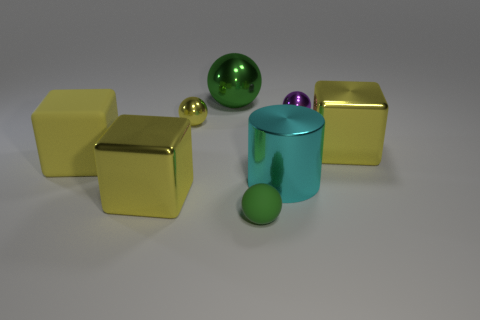Are there any other things that have the same color as the large cylinder?
Provide a short and direct response. No. What is the color of the matte thing that is the same size as the cylinder?
Give a very brief answer. Yellow. Are there fewer large yellow shiny cubes that are right of the small green thing than yellow blocks that are to the right of the yellow matte cube?
Provide a succinct answer. Yes. There is a yellow metallic block left of the purple shiny object; is it the same size as the small yellow metallic ball?
Make the answer very short. No. What is the shape of the yellow object that is to the right of the green rubber ball?
Ensure brevity in your answer.  Cube. Is the number of green shiny spheres greater than the number of green balls?
Offer a very short reply. No. There is a block behind the yellow rubber object; does it have the same color as the big rubber cube?
Ensure brevity in your answer.  Yes. What number of things are small metal things that are on the left side of the big green metallic object or large shiny things in front of the tiny purple shiny thing?
Your response must be concise. 4. What number of tiny things are to the right of the green metallic sphere and behind the cyan cylinder?
Ensure brevity in your answer.  1. Do the yellow ball and the small green ball have the same material?
Your answer should be compact. No. 